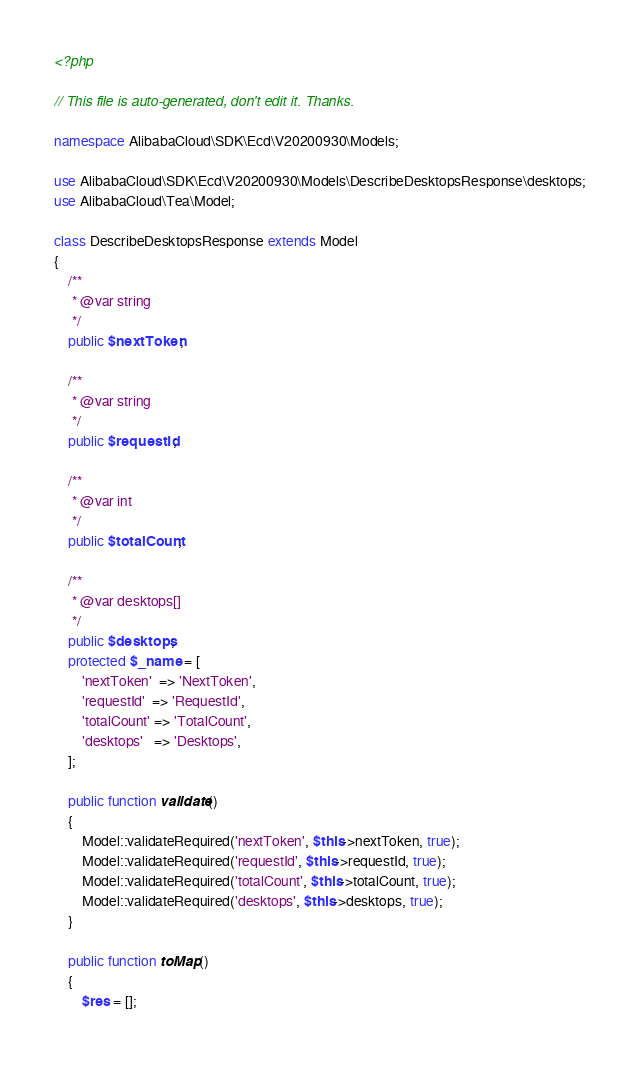<code> <loc_0><loc_0><loc_500><loc_500><_PHP_><?php

// This file is auto-generated, don't edit it. Thanks.

namespace AlibabaCloud\SDK\Ecd\V20200930\Models;

use AlibabaCloud\SDK\Ecd\V20200930\Models\DescribeDesktopsResponse\desktops;
use AlibabaCloud\Tea\Model;

class DescribeDesktopsResponse extends Model
{
    /**
     * @var string
     */
    public $nextToken;

    /**
     * @var string
     */
    public $requestId;

    /**
     * @var int
     */
    public $totalCount;

    /**
     * @var desktops[]
     */
    public $desktops;
    protected $_name = [
        'nextToken'  => 'NextToken',
        'requestId'  => 'RequestId',
        'totalCount' => 'TotalCount',
        'desktops'   => 'Desktops',
    ];

    public function validate()
    {
        Model::validateRequired('nextToken', $this->nextToken, true);
        Model::validateRequired('requestId', $this->requestId, true);
        Model::validateRequired('totalCount', $this->totalCount, true);
        Model::validateRequired('desktops', $this->desktops, true);
    }

    public function toMap()
    {
        $res = [];</code> 